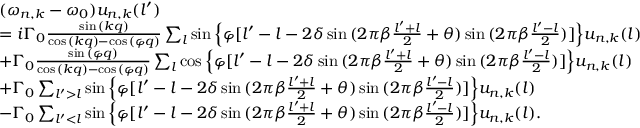<formula> <loc_0><loc_0><loc_500><loc_500>\begin{array} { r l } & { ( \omega _ { n , k } - \omega _ { 0 } ) u _ { n , k } ( l ^ { \prime } ) } \\ & { = i \Gamma _ { 0 } \frac { \sin { ( k q ) } } { \cos { ( k q ) } - \cos { ( \varphi q ) } } \sum _ { l } \sin { \left \{ \varphi [ l ^ { \prime } - l - 2 \delta \sin { ( 2 \pi \beta \frac { l ^ { \prime } + l } { 2 } + \theta ) } \sin { ( 2 \pi \beta \frac { l ^ { \prime } - l } { 2 } ) } ] \right \} } u _ { n , k } ( l ) } \\ & { + \Gamma _ { 0 } \frac { \sin { ( \varphi q ) } } { \cos { ( k q ) } - \cos { ( \varphi q ) } } \sum _ { l } \cos { \left \{ \varphi [ l ^ { \prime } - l - 2 \delta \sin { ( 2 \pi \beta \frac { l ^ { \prime } + l } { 2 } + \theta ) } \sin { ( 2 \pi \beta \frac { l ^ { \prime } - l } { 2 } ) } ] \right \} } u _ { n , k } ( l ) } \\ & { + \Gamma _ { 0 } \sum _ { l ^ { \prime } > l } \sin { \left \{ \varphi [ l ^ { \prime } - l - 2 \delta \sin { ( 2 \pi \beta \frac { l ^ { \prime } + l } { 2 } + \theta ) } \sin { ( 2 \pi \beta \frac { l ^ { \prime } - l } { 2 } ) } ] \right \} } u _ { n , k } ( l ) } \\ & { - \Gamma _ { 0 } \sum _ { l ^ { \prime } < l } \sin { \left \{ \varphi [ l ^ { \prime } - l - 2 \delta \sin { ( 2 \pi \beta \frac { l ^ { \prime } + l } { 2 } + \theta ) } \sin { ( 2 \pi \beta \frac { l ^ { \prime } - l } { 2 } ) } ] \right \} } u _ { n , k } ( l ) . } \end{array}</formula> 